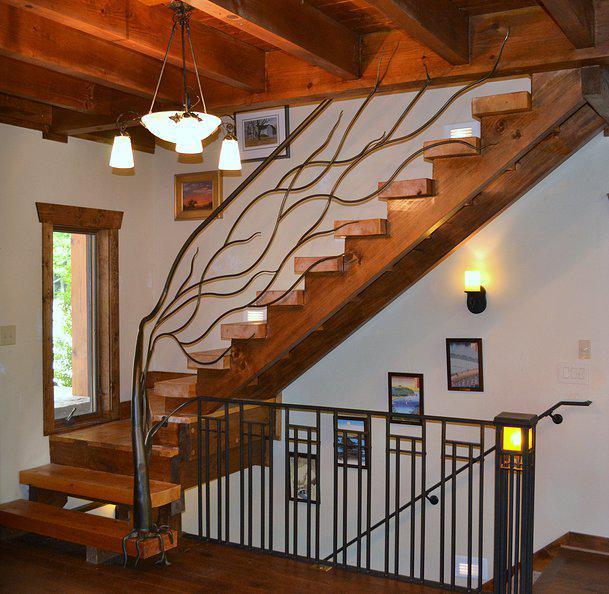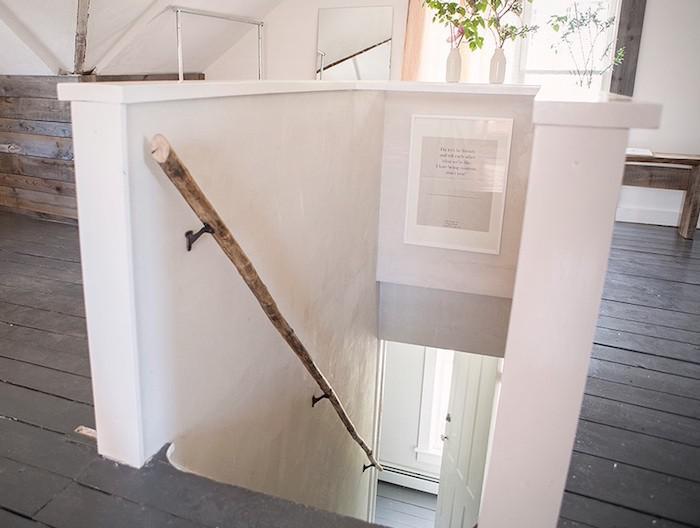The first image is the image on the left, the second image is the image on the right. For the images displayed, is the sentence "In the left image, a tree shape with a trunk at the base of the staircase has branches forming the railing as the stairs ascend rightward." factually correct? Answer yes or no. Yes. The first image is the image on the left, the second image is the image on the right. Assess this claim about the two images: "One of the stair rails looks like a single branch from a tree.". Correct or not? Answer yes or no. Yes. 